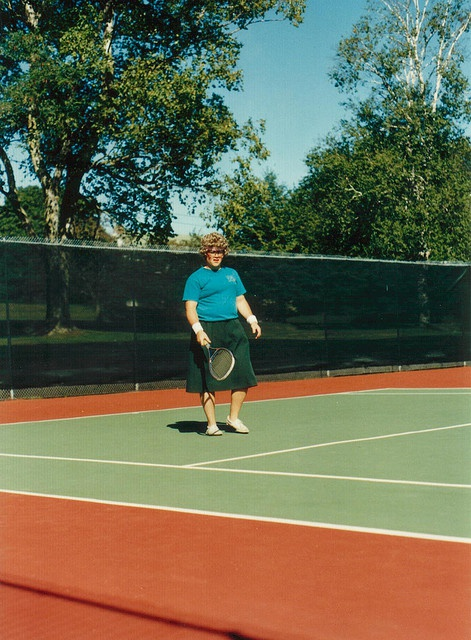Describe the objects in this image and their specific colors. I can see people in darkgreen, black, teal, and tan tones and tennis racket in darkgreen, gray, black, and darkgray tones in this image. 